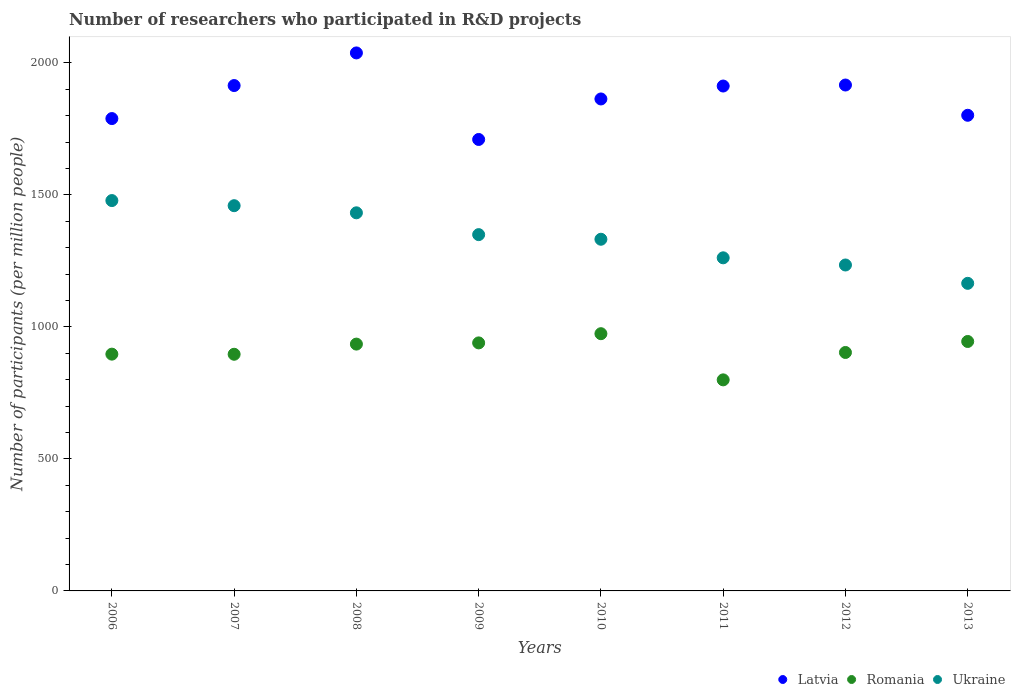Is the number of dotlines equal to the number of legend labels?
Your answer should be very brief. Yes. What is the number of researchers who participated in R&D projects in Ukraine in 2011?
Make the answer very short. 1261.86. Across all years, what is the maximum number of researchers who participated in R&D projects in Romania?
Offer a terse response. 974.44. Across all years, what is the minimum number of researchers who participated in R&D projects in Latvia?
Keep it short and to the point. 1710.19. In which year was the number of researchers who participated in R&D projects in Romania maximum?
Make the answer very short. 2010. What is the total number of researchers who participated in R&D projects in Ukraine in the graph?
Make the answer very short. 1.07e+04. What is the difference between the number of researchers who participated in R&D projects in Romania in 2006 and that in 2010?
Provide a short and direct response. -77.48. What is the difference between the number of researchers who participated in R&D projects in Latvia in 2006 and the number of researchers who participated in R&D projects in Ukraine in 2007?
Your response must be concise. 330.04. What is the average number of researchers who participated in R&D projects in Romania per year?
Keep it short and to the point. 911.28. In the year 2006, what is the difference between the number of researchers who participated in R&D projects in Latvia and number of researchers who participated in R&D projects in Ukraine?
Your response must be concise. 310.65. In how many years, is the number of researchers who participated in R&D projects in Latvia greater than 1100?
Offer a terse response. 8. What is the ratio of the number of researchers who participated in R&D projects in Ukraine in 2009 to that in 2011?
Keep it short and to the point. 1.07. What is the difference between the highest and the second highest number of researchers who participated in R&D projects in Latvia?
Offer a very short reply. 121.58. What is the difference between the highest and the lowest number of researchers who participated in R&D projects in Romania?
Ensure brevity in your answer.  174.9. In how many years, is the number of researchers who participated in R&D projects in Romania greater than the average number of researchers who participated in R&D projects in Romania taken over all years?
Keep it short and to the point. 4. Is it the case that in every year, the sum of the number of researchers who participated in R&D projects in Romania and number of researchers who participated in R&D projects in Ukraine  is greater than the number of researchers who participated in R&D projects in Latvia?
Provide a short and direct response. Yes. Is the number of researchers who participated in R&D projects in Latvia strictly greater than the number of researchers who participated in R&D projects in Romania over the years?
Your answer should be compact. Yes. How many years are there in the graph?
Offer a terse response. 8. Are the values on the major ticks of Y-axis written in scientific E-notation?
Offer a very short reply. No. Does the graph contain grids?
Your answer should be compact. No. How many legend labels are there?
Make the answer very short. 3. How are the legend labels stacked?
Give a very brief answer. Horizontal. What is the title of the graph?
Give a very brief answer. Number of researchers who participated in R&D projects. Does "Guinea" appear as one of the legend labels in the graph?
Your response must be concise. No. What is the label or title of the X-axis?
Provide a short and direct response. Years. What is the label or title of the Y-axis?
Provide a short and direct response. Number of participants (per million people). What is the Number of participants (per million people) in Latvia in 2006?
Make the answer very short. 1789.36. What is the Number of participants (per million people) in Romania in 2006?
Keep it short and to the point. 896.96. What is the Number of participants (per million people) of Ukraine in 2006?
Your response must be concise. 1478.72. What is the Number of participants (per million people) in Latvia in 2007?
Provide a short and direct response. 1914.45. What is the Number of participants (per million people) of Romania in 2007?
Offer a very short reply. 896.49. What is the Number of participants (per million people) of Ukraine in 2007?
Make the answer very short. 1459.32. What is the Number of participants (per million people) of Latvia in 2008?
Offer a terse response. 2038.04. What is the Number of participants (per million people) of Romania in 2008?
Your response must be concise. 935.03. What is the Number of participants (per million people) in Ukraine in 2008?
Your response must be concise. 1432.33. What is the Number of participants (per million people) in Latvia in 2009?
Keep it short and to the point. 1710.19. What is the Number of participants (per million people) in Romania in 2009?
Your answer should be compact. 939.58. What is the Number of participants (per million people) in Ukraine in 2009?
Your answer should be very brief. 1349.71. What is the Number of participants (per million people) of Latvia in 2010?
Ensure brevity in your answer.  1863.65. What is the Number of participants (per million people) in Romania in 2010?
Your answer should be very brief. 974.44. What is the Number of participants (per million people) in Ukraine in 2010?
Keep it short and to the point. 1332.2. What is the Number of participants (per million people) in Latvia in 2011?
Your answer should be compact. 1912.62. What is the Number of participants (per million people) of Romania in 2011?
Your answer should be very brief. 799.54. What is the Number of participants (per million people) in Ukraine in 2011?
Give a very brief answer. 1261.86. What is the Number of participants (per million people) in Latvia in 2012?
Offer a very short reply. 1916.46. What is the Number of participants (per million people) in Romania in 2012?
Your answer should be very brief. 903.29. What is the Number of participants (per million people) of Ukraine in 2012?
Your answer should be compact. 1234.66. What is the Number of participants (per million people) of Latvia in 2013?
Provide a succinct answer. 1801.82. What is the Number of participants (per million people) of Romania in 2013?
Make the answer very short. 944.93. What is the Number of participants (per million people) of Ukraine in 2013?
Your response must be concise. 1165.18. Across all years, what is the maximum Number of participants (per million people) of Latvia?
Keep it short and to the point. 2038.04. Across all years, what is the maximum Number of participants (per million people) in Romania?
Keep it short and to the point. 974.44. Across all years, what is the maximum Number of participants (per million people) in Ukraine?
Keep it short and to the point. 1478.72. Across all years, what is the minimum Number of participants (per million people) in Latvia?
Make the answer very short. 1710.19. Across all years, what is the minimum Number of participants (per million people) in Romania?
Keep it short and to the point. 799.54. Across all years, what is the minimum Number of participants (per million people) of Ukraine?
Offer a terse response. 1165.18. What is the total Number of participants (per million people) in Latvia in the graph?
Offer a terse response. 1.49e+04. What is the total Number of participants (per million people) in Romania in the graph?
Keep it short and to the point. 7290.24. What is the total Number of participants (per million people) of Ukraine in the graph?
Give a very brief answer. 1.07e+04. What is the difference between the Number of participants (per million people) in Latvia in 2006 and that in 2007?
Your answer should be very brief. -125.09. What is the difference between the Number of participants (per million people) in Romania in 2006 and that in 2007?
Your answer should be compact. 0.48. What is the difference between the Number of participants (per million people) of Ukraine in 2006 and that in 2007?
Provide a short and direct response. 19.39. What is the difference between the Number of participants (per million people) of Latvia in 2006 and that in 2008?
Give a very brief answer. -248.68. What is the difference between the Number of participants (per million people) in Romania in 2006 and that in 2008?
Ensure brevity in your answer.  -38.06. What is the difference between the Number of participants (per million people) of Ukraine in 2006 and that in 2008?
Your answer should be very brief. 46.39. What is the difference between the Number of participants (per million people) of Latvia in 2006 and that in 2009?
Your answer should be compact. 79.17. What is the difference between the Number of participants (per million people) of Romania in 2006 and that in 2009?
Give a very brief answer. -42.61. What is the difference between the Number of participants (per million people) of Ukraine in 2006 and that in 2009?
Offer a terse response. 129. What is the difference between the Number of participants (per million people) in Latvia in 2006 and that in 2010?
Your answer should be compact. -74.29. What is the difference between the Number of participants (per million people) of Romania in 2006 and that in 2010?
Your response must be concise. -77.48. What is the difference between the Number of participants (per million people) in Ukraine in 2006 and that in 2010?
Provide a succinct answer. 146.52. What is the difference between the Number of participants (per million people) of Latvia in 2006 and that in 2011?
Keep it short and to the point. -123.26. What is the difference between the Number of participants (per million people) in Romania in 2006 and that in 2011?
Provide a short and direct response. 97.43. What is the difference between the Number of participants (per million people) in Ukraine in 2006 and that in 2011?
Your answer should be compact. 216.86. What is the difference between the Number of participants (per million people) in Latvia in 2006 and that in 2012?
Ensure brevity in your answer.  -127.09. What is the difference between the Number of participants (per million people) of Romania in 2006 and that in 2012?
Ensure brevity in your answer.  -6.32. What is the difference between the Number of participants (per million people) in Ukraine in 2006 and that in 2012?
Provide a short and direct response. 244.05. What is the difference between the Number of participants (per million people) of Latvia in 2006 and that in 2013?
Provide a succinct answer. -12.45. What is the difference between the Number of participants (per million people) in Romania in 2006 and that in 2013?
Give a very brief answer. -47.96. What is the difference between the Number of participants (per million people) in Ukraine in 2006 and that in 2013?
Your answer should be compact. 313.53. What is the difference between the Number of participants (per million people) in Latvia in 2007 and that in 2008?
Offer a terse response. -123.59. What is the difference between the Number of participants (per million people) of Romania in 2007 and that in 2008?
Offer a very short reply. -38.54. What is the difference between the Number of participants (per million people) of Ukraine in 2007 and that in 2008?
Keep it short and to the point. 26.99. What is the difference between the Number of participants (per million people) in Latvia in 2007 and that in 2009?
Your response must be concise. 204.26. What is the difference between the Number of participants (per million people) in Romania in 2007 and that in 2009?
Give a very brief answer. -43.09. What is the difference between the Number of participants (per million people) of Ukraine in 2007 and that in 2009?
Provide a short and direct response. 109.61. What is the difference between the Number of participants (per million people) of Latvia in 2007 and that in 2010?
Provide a short and direct response. 50.8. What is the difference between the Number of participants (per million people) of Romania in 2007 and that in 2010?
Your response must be concise. -77.95. What is the difference between the Number of participants (per million people) in Ukraine in 2007 and that in 2010?
Your response must be concise. 127.12. What is the difference between the Number of participants (per million people) in Latvia in 2007 and that in 2011?
Provide a short and direct response. 1.83. What is the difference between the Number of participants (per million people) in Romania in 2007 and that in 2011?
Your answer should be compact. 96.95. What is the difference between the Number of participants (per million people) in Ukraine in 2007 and that in 2011?
Your response must be concise. 197.46. What is the difference between the Number of participants (per million people) in Latvia in 2007 and that in 2012?
Provide a short and direct response. -2.01. What is the difference between the Number of participants (per million people) in Romania in 2007 and that in 2012?
Give a very brief answer. -6.8. What is the difference between the Number of participants (per million people) in Ukraine in 2007 and that in 2012?
Provide a short and direct response. 224.66. What is the difference between the Number of participants (per million people) of Latvia in 2007 and that in 2013?
Keep it short and to the point. 112.63. What is the difference between the Number of participants (per million people) of Romania in 2007 and that in 2013?
Keep it short and to the point. -48.44. What is the difference between the Number of participants (per million people) of Ukraine in 2007 and that in 2013?
Your answer should be very brief. 294.14. What is the difference between the Number of participants (per million people) in Latvia in 2008 and that in 2009?
Make the answer very short. 327.85. What is the difference between the Number of participants (per million people) in Romania in 2008 and that in 2009?
Provide a short and direct response. -4.55. What is the difference between the Number of participants (per million people) in Ukraine in 2008 and that in 2009?
Offer a very short reply. 82.62. What is the difference between the Number of participants (per million people) in Latvia in 2008 and that in 2010?
Offer a terse response. 174.39. What is the difference between the Number of participants (per million people) in Romania in 2008 and that in 2010?
Your answer should be compact. -39.41. What is the difference between the Number of participants (per million people) of Ukraine in 2008 and that in 2010?
Keep it short and to the point. 100.13. What is the difference between the Number of participants (per million people) in Latvia in 2008 and that in 2011?
Offer a terse response. 125.42. What is the difference between the Number of participants (per million people) in Romania in 2008 and that in 2011?
Your answer should be compact. 135.49. What is the difference between the Number of participants (per million people) in Ukraine in 2008 and that in 2011?
Provide a succinct answer. 170.47. What is the difference between the Number of participants (per million people) of Latvia in 2008 and that in 2012?
Offer a very short reply. 121.58. What is the difference between the Number of participants (per million people) of Romania in 2008 and that in 2012?
Your response must be concise. 31.74. What is the difference between the Number of participants (per million people) of Ukraine in 2008 and that in 2012?
Make the answer very short. 197.67. What is the difference between the Number of participants (per million people) of Latvia in 2008 and that in 2013?
Your answer should be very brief. 236.22. What is the difference between the Number of participants (per million people) of Romania in 2008 and that in 2013?
Your answer should be very brief. -9.9. What is the difference between the Number of participants (per million people) in Ukraine in 2008 and that in 2013?
Give a very brief answer. 267.15. What is the difference between the Number of participants (per million people) of Latvia in 2009 and that in 2010?
Offer a terse response. -153.46. What is the difference between the Number of participants (per million people) of Romania in 2009 and that in 2010?
Your response must be concise. -34.86. What is the difference between the Number of participants (per million people) in Ukraine in 2009 and that in 2010?
Keep it short and to the point. 17.51. What is the difference between the Number of participants (per million people) of Latvia in 2009 and that in 2011?
Your answer should be very brief. -202.43. What is the difference between the Number of participants (per million people) of Romania in 2009 and that in 2011?
Your answer should be very brief. 140.04. What is the difference between the Number of participants (per million people) of Ukraine in 2009 and that in 2011?
Your response must be concise. 87.85. What is the difference between the Number of participants (per million people) in Latvia in 2009 and that in 2012?
Your answer should be very brief. -206.27. What is the difference between the Number of participants (per million people) in Romania in 2009 and that in 2012?
Offer a very short reply. 36.29. What is the difference between the Number of participants (per million people) of Ukraine in 2009 and that in 2012?
Give a very brief answer. 115.05. What is the difference between the Number of participants (per million people) of Latvia in 2009 and that in 2013?
Your answer should be compact. -91.63. What is the difference between the Number of participants (per million people) of Romania in 2009 and that in 2013?
Offer a very short reply. -5.35. What is the difference between the Number of participants (per million people) in Ukraine in 2009 and that in 2013?
Provide a short and direct response. 184.53. What is the difference between the Number of participants (per million people) in Latvia in 2010 and that in 2011?
Your answer should be compact. -48.97. What is the difference between the Number of participants (per million people) in Romania in 2010 and that in 2011?
Make the answer very short. 174.9. What is the difference between the Number of participants (per million people) of Ukraine in 2010 and that in 2011?
Offer a terse response. 70.34. What is the difference between the Number of participants (per million people) of Latvia in 2010 and that in 2012?
Give a very brief answer. -52.81. What is the difference between the Number of participants (per million people) of Romania in 2010 and that in 2012?
Provide a succinct answer. 71.15. What is the difference between the Number of participants (per million people) in Ukraine in 2010 and that in 2012?
Give a very brief answer. 97.54. What is the difference between the Number of participants (per million people) of Latvia in 2010 and that in 2013?
Your answer should be compact. 61.83. What is the difference between the Number of participants (per million people) of Romania in 2010 and that in 2013?
Your answer should be very brief. 29.52. What is the difference between the Number of participants (per million people) of Ukraine in 2010 and that in 2013?
Keep it short and to the point. 167.02. What is the difference between the Number of participants (per million people) of Latvia in 2011 and that in 2012?
Your response must be concise. -3.84. What is the difference between the Number of participants (per million people) in Romania in 2011 and that in 2012?
Keep it short and to the point. -103.75. What is the difference between the Number of participants (per million people) of Ukraine in 2011 and that in 2012?
Provide a succinct answer. 27.2. What is the difference between the Number of participants (per million people) of Latvia in 2011 and that in 2013?
Give a very brief answer. 110.8. What is the difference between the Number of participants (per million people) in Romania in 2011 and that in 2013?
Give a very brief answer. -145.39. What is the difference between the Number of participants (per million people) in Ukraine in 2011 and that in 2013?
Ensure brevity in your answer.  96.68. What is the difference between the Number of participants (per million people) of Latvia in 2012 and that in 2013?
Offer a terse response. 114.64. What is the difference between the Number of participants (per million people) in Romania in 2012 and that in 2013?
Provide a succinct answer. -41.64. What is the difference between the Number of participants (per million people) of Ukraine in 2012 and that in 2013?
Make the answer very short. 69.48. What is the difference between the Number of participants (per million people) of Latvia in 2006 and the Number of participants (per million people) of Romania in 2007?
Your answer should be compact. 892.88. What is the difference between the Number of participants (per million people) in Latvia in 2006 and the Number of participants (per million people) in Ukraine in 2007?
Offer a very short reply. 330.04. What is the difference between the Number of participants (per million people) in Romania in 2006 and the Number of participants (per million people) in Ukraine in 2007?
Give a very brief answer. -562.36. What is the difference between the Number of participants (per million people) in Latvia in 2006 and the Number of participants (per million people) in Romania in 2008?
Offer a terse response. 854.34. What is the difference between the Number of participants (per million people) of Latvia in 2006 and the Number of participants (per million people) of Ukraine in 2008?
Offer a terse response. 357.04. What is the difference between the Number of participants (per million people) in Romania in 2006 and the Number of participants (per million people) in Ukraine in 2008?
Your answer should be very brief. -535.36. What is the difference between the Number of participants (per million people) of Latvia in 2006 and the Number of participants (per million people) of Romania in 2009?
Provide a short and direct response. 849.79. What is the difference between the Number of participants (per million people) of Latvia in 2006 and the Number of participants (per million people) of Ukraine in 2009?
Give a very brief answer. 439.65. What is the difference between the Number of participants (per million people) in Romania in 2006 and the Number of participants (per million people) in Ukraine in 2009?
Make the answer very short. -452.75. What is the difference between the Number of participants (per million people) of Latvia in 2006 and the Number of participants (per million people) of Romania in 2010?
Your answer should be very brief. 814.92. What is the difference between the Number of participants (per million people) of Latvia in 2006 and the Number of participants (per million people) of Ukraine in 2010?
Offer a very short reply. 457.17. What is the difference between the Number of participants (per million people) in Romania in 2006 and the Number of participants (per million people) in Ukraine in 2010?
Give a very brief answer. -435.23. What is the difference between the Number of participants (per million people) in Latvia in 2006 and the Number of participants (per million people) in Romania in 2011?
Your answer should be compact. 989.83. What is the difference between the Number of participants (per million people) of Latvia in 2006 and the Number of participants (per million people) of Ukraine in 2011?
Your response must be concise. 527.5. What is the difference between the Number of participants (per million people) of Romania in 2006 and the Number of participants (per million people) of Ukraine in 2011?
Keep it short and to the point. -364.9. What is the difference between the Number of participants (per million people) in Latvia in 2006 and the Number of participants (per million people) in Romania in 2012?
Your response must be concise. 886.08. What is the difference between the Number of participants (per million people) in Latvia in 2006 and the Number of participants (per million people) in Ukraine in 2012?
Your answer should be very brief. 554.7. What is the difference between the Number of participants (per million people) of Romania in 2006 and the Number of participants (per million people) of Ukraine in 2012?
Make the answer very short. -337.7. What is the difference between the Number of participants (per million people) in Latvia in 2006 and the Number of participants (per million people) in Romania in 2013?
Your response must be concise. 844.44. What is the difference between the Number of participants (per million people) in Latvia in 2006 and the Number of participants (per million people) in Ukraine in 2013?
Give a very brief answer. 624.18. What is the difference between the Number of participants (per million people) of Romania in 2006 and the Number of participants (per million people) of Ukraine in 2013?
Your response must be concise. -268.22. What is the difference between the Number of participants (per million people) in Latvia in 2007 and the Number of participants (per million people) in Romania in 2008?
Make the answer very short. 979.43. What is the difference between the Number of participants (per million people) of Latvia in 2007 and the Number of participants (per million people) of Ukraine in 2008?
Ensure brevity in your answer.  482.12. What is the difference between the Number of participants (per million people) in Romania in 2007 and the Number of participants (per million people) in Ukraine in 2008?
Give a very brief answer. -535.84. What is the difference between the Number of participants (per million people) in Latvia in 2007 and the Number of participants (per million people) in Romania in 2009?
Give a very brief answer. 974.87. What is the difference between the Number of participants (per million people) of Latvia in 2007 and the Number of participants (per million people) of Ukraine in 2009?
Provide a succinct answer. 564.74. What is the difference between the Number of participants (per million people) of Romania in 2007 and the Number of participants (per million people) of Ukraine in 2009?
Your answer should be compact. -453.23. What is the difference between the Number of participants (per million people) in Latvia in 2007 and the Number of participants (per million people) in Romania in 2010?
Keep it short and to the point. 940.01. What is the difference between the Number of participants (per million people) of Latvia in 2007 and the Number of participants (per million people) of Ukraine in 2010?
Provide a succinct answer. 582.25. What is the difference between the Number of participants (per million people) in Romania in 2007 and the Number of participants (per million people) in Ukraine in 2010?
Make the answer very short. -435.71. What is the difference between the Number of participants (per million people) of Latvia in 2007 and the Number of participants (per million people) of Romania in 2011?
Ensure brevity in your answer.  1114.92. What is the difference between the Number of participants (per million people) of Latvia in 2007 and the Number of participants (per million people) of Ukraine in 2011?
Your answer should be compact. 652.59. What is the difference between the Number of participants (per million people) in Romania in 2007 and the Number of participants (per million people) in Ukraine in 2011?
Give a very brief answer. -365.38. What is the difference between the Number of participants (per million people) of Latvia in 2007 and the Number of participants (per million people) of Romania in 2012?
Offer a terse response. 1011.17. What is the difference between the Number of participants (per million people) of Latvia in 2007 and the Number of participants (per million people) of Ukraine in 2012?
Your answer should be very brief. 679.79. What is the difference between the Number of participants (per million people) in Romania in 2007 and the Number of participants (per million people) in Ukraine in 2012?
Offer a very short reply. -338.18. What is the difference between the Number of participants (per million people) in Latvia in 2007 and the Number of participants (per million people) in Romania in 2013?
Your response must be concise. 969.53. What is the difference between the Number of participants (per million people) of Latvia in 2007 and the Number of participants (per million people) of Ukraine in 2013?
Ensure brevity in your answer.  749.27. What is the difference between the Number of participants (per million people) in Romania in 2007 and the Number of participants (per million people) in Ukraine in 2013?
Your answer should be compact. -268.7. What is the difference between the Number of participants (per million people) of Latvia in 2008 and the Number of participants (per million people) of Romania in 2009?
Your response must be concise. 1098.46. What is the difference between the Number of participants (per million people) in Latvia in 2008 and the Number of participants (per million people) in Ukraine in 2009?
Your answer should be very brief. 688.33. What is the difference between the Number of participants (per million people) in Romania in 2008 and the Number of participants (per million people) in Ukraine in 2009?
Give a very brief answer. -414.68. What is the difference between the Number of participants (per million people) in Latvia in 2008 and the Number of participants (per million people) in Romania in 2010?
Your response must be concise. 1063.6. What is the difference between the Number of participants (per million people) of Latvia in 2008 and the Number of participants (per million people) of Ukraine in 2010?
Provide a short and direct response. 705.84. What is the difference between the Number of participants (per million people) in Romania in 2008 and the Number of participants (per million people) in Ukraine in 2010?
Your answer should be compact. -397.17. What is the difference between the Number of participants (per million people) of Latvia in 2008 and the Number of participants (per million people) of Romania in 2011?
Ensure brevity in your answer.  1238.51. What is the difference between the Number of participants (per million people) of Latvia in 2008 and the Number of participants (per million people) of Ukraine in 2011?
Offer a terse response. 776.18. What is the difference between the Number of participants (per million people) in Romania in 2008 and the Number of participants (per million people) in Ukraine in 2011?
Your answer should be very brief. -326.83. What is the difference between the Number of participants (per million people) of Latvia in 2008 and the Number of participants (per million people) of Romania in 2012?
Your answer should be compact. 1134.76. What is the difference between the Number of participants (per million people) of Latvia in 2008 and the Number of participants (per million people) of Ukraine in 2012?
Your answer should be very brief. 803.38. What is the difference between the Number of participants (per million people) in Romania in 2008 and the Number of participants (per million people) in Ukraine in 2012?
Ensure brevity in your answer.  -299.64. What is the difference between the Number of participants (per million people) in Latvia in 2008 and the Number of participants (per million people) in Romania in 2013?
Provide a succinct answer. 1093.12. What is the difference between the Number of participants (per million people) of Latvia in 2008 and the Number of participants (per million people) of Ukraine in 2013?
Your answer should be very brief. 872.86. What is the difference between the Number of participants (per million people) in Romania in 2008 and the Number of participants (per million people) in Ukraine in 2013?
Provide a short and direct response. -230.16. What is the difference between the Number of participants (per million people) of Latvia in 2009 and the Number of participants (per million people) of Romania in 2010?
Keep it short and to the point. 735.75. What is the difference between the Number of participants (per million people) in Latvia in 2009 and the Number of participants (per million people) in Ukraine in 2010?
Keep it short and to the point. 377.99. What is the difference between the Number of participants (per million people) of Romania in 2009 and the Number of participants (per million people) of Ukraine in 2010?
Your answer should be compact. -392.62. What is the difference between the Number of participants (per million people) in Latvia in 2009 and the Number of participants (per million people) in Romania in 2011?
Keep it short and to the point. 910.66. What is the difference between the Number of participants (per million people) in Latvia in 2009 and the Number of participants (per million people) in Ukraine in 2011?
Your answer should be very brief. 448.33. What is the difference between the Number of participants (per million people) in Romania in 2009 and the Number of participants (per million people) in Ukraine in 2011?
Provide a succinct answer. -322.28. What is the difference between the Number of participants (per million people) in Latvia in 2009 and the Number of participants (per million people) in Romania in 2012?
Ensure brevity in your answer.  806.91. What is the difference between the Number of participants (per million people) in Latvia in 2009 and the Number of participants (per million people) in Ukraine in 2012?
Provide a short and direct response. 475.53. What is the difference between the Number of participants (per million people) in Romania in 2009 and the Number of participants (per million people) in Ukraine in 2012?
Provide a succinct answer. -295.08. What is the difference between the Number of participants (per million people) in Latvia in 2009 and the Number of participants (per million people) in Romania in 2013?
Your response must be concise. 765.27. What is the difference between the Number of participants (per million people) in Latvia in 2009 and the Number of participants (per million people) in Ukraine in 2013?
Your answer should be compact. 545.01. What is the difference between the Number of participants (per million people) in Romania in 2009 and the Number of participants (per million people) in Ukraine in 2013?
Offer a very short reply. -225.6. What is the difference between the Number of participants (per million people) in Latvia in 2010 and the Number of participants (per million people) in Romania in 2011?
Provide a succinct answer. 1064.12. What is the difference between the Number of participants (per million people) of Latvia in 2010 and the Number of participants (per million people) of Ukraine in 2011?
Offer a very short reply. 601.79. What is the difference between the Number of participants (per million people) of Romania in 2010 and the Number of participants (per million people) of Ukraine in 2011?
Your answer should be very brief. -287.42. What is the difference between the Number of participants (per million people) in Latvia in 2010 and the Number of participants (per million people) in Romania in 2012?
Your response must be concise. 960.37. What is the difference between the Number of participants (per million people) in Latvia in 2010 and the Number of participants (per million people) in Ukraine in 2012?
Your answer should be very brief. 628.99. What is the difference between the Number of participants (per million people) in Romania in 2010 and the Number of participants (per million people) in Ukraine in 2012?
Make the answer very short. -260.22. What is the difference between the Number of participants (per million people) of Latvia in 2010 and the Number of participants (per million people) of Romania in 2013?
Your answer should be very brief. 918.73. What is the difference between the Number of participants (per million people) in Latvia in 2010 and the Number of participants (per million people) in Ukraine in 2013?
Offer a terse response. 698.47. What is the difference between the Number of participants (per million people) in Romania in 2010 and the Number of participants (per million people) in Ukraine in 2013?
Your response must be concise. -190.74. What is the difference between the Number of participants (per million people) in Latvia in 2011 and the Number of participants (per million people) in Romania in 2012?
Provide a succinct answer. 1009.33. What is the difference between the Number of participants (per million people) in Latvia in 2011 and the Number of participants (per million people) in Ukraine in 2012?
Keep it short and to the point. 677.96. What is the difference between the Number of participants (per million people) of Romania in 2011 and the Number of participants (per million people) of Ukraine in 2012?
Give a very brief answer. -435.13. What is the difference between the Number of participants (per million people) of Latvia in 2011 and the Number of participants (per million people) of Romania in 2013?
Keep it short and to the point. 967.7. What is the difference between the Number of participants (per million people) in Latvia in 2011 and the Number of participants (per million people) in Ukraine in 2013?
Offer a very short reply. 747.44. What is the difference between the Number of participants (per million people) of Romania in 2011 and the Number of participants (per million people) of Ukraine in 2013?
Provide a succinct answer. -365.65. What is the difference between the Number of participants (per million people) of Latvia in 2012 and the Number of participants (per million people) of Romania in 2013?
Keep it short and to the point. 971.53. What is the difference between the Number of participants (per million people) in Latvia in 2012 and the Number of participants (per million people) in Ukraine in 2013?
Offer a very short reply. 751.28. What is the difference between the Number of participants (per million people) of Romania in 2012 and the Number of participants (per million people) of Ukraine in 2013?
Ensure brevity in your answer.  -261.9. What is the average Number of participants (per million people) of Latvia per year?
Ensure brevity in your answer.  1868.32. What is the average Number of participants (per million people) of Romania per year?
Provide a succinct answer. 911.28. What is the average Number of participants (per million people) of Ukraine per year?
Keep it short and to the point. 1339.25. In the year 2006, what is the difference between the Number of participants (per million people) of Latvia and Number of participants (per million people) of Romania?
Give a very brief answer. 892.4. In the year 2006, what is the difference between the Number of participants (per million people) in Latvia and Number of participants (per million people) in Ukraine?
Your answer should be compact. 310.65. In the year 2006, what is the difference between the Number of participants (per million people) of Romania and Number of participants (per million people) of Ukraine?
Offer a very short reply. -581.75. In the year 2007, what is the difference between the Number of participants (per million people) in Latvia and Number of participants (per million people) in Romania?
Give a very brief answer. 1017.97. In the year 2007, what is the difference between the Number of participants (per million people) of Latvia and Number of participants (per million people) of Ukraine?
Offer a very short reply. 455.13. In the year 2007, what is the difference between the Number of participants (per million people) of Romania and Number of participants (per million people) of Ukraine?
Make the answer very short. -562.84. In the year 2008, what is the difference between the Number of participants (per million people) of Latvia and Number of participants (per million people) of Romania?
Provide a succinct answer. 1103.02. In the year 2008, what is the difference between the Number of participants (per million people) of Latvia and Number of participants (per million people) of Ukraine?
Your response must be concise. 605.71. In the year 2008, what is the difference between the Number of participants (per million people) in Romania and Number of participants (per million people) in Ukraine?
Offer a terse response. -497.3. In the year 2009, what is the difference between the Number of participants (per million people) of Latvia and Number of participants (per million people) of Romania?
Ensure brevity in your answer.  770.61. In the year 2009, what is the difference between the Number of participants (per million people) in Latvia and Number of participants (per million people) in Ukraine?
Make the answer very short. 360.48. In the year 2009, what is the difference between the Number of participants (per million people) of Romania and Number of participants (per million people) of Ukraine?
Offer a terse response. -410.13. In the year 2010, what is the difference between the Number of participants (per million people) in Latvia and Number of participants (per million people) in Romania?
Keep it short and to the point. 889.21. In the year 2010, what is the difference between the Number of participants (per million people) of Latvia and Number of participants (per million people) of Ukraine?
Provide a succinct answer. 531.45. In the year 2010, what is the difference between the Number of participants (per million people) of Romania and Number of participants (per million people) of Ukraine?
Make the answer very short. -357.76. In the year 2011, what is the difference between the Number of participants (per million people) in Latvia and Number of participants (per million people) in Romania?
Keep it short and to the point. 1113.08. In the year 2011, what is the difference between the Number of participants (per million people) of Latvia and Number of participants (per million people) of Ukraine?
Offer a very short reply. 650.76. In the year 2011, what is the difference between the Number of participants (per million people) of Romania and Number of participants (per million people) of Ukraine?
Provide a succinct answer. -462.32. In the year 2012, what is the difference between the Number of participants (per million people) in Latvia and Number of participants (per million people) in Romania?
Offer a very short reply. 1013.17. In the year 2012, what is the difference between the Number of participants (per million people) in Latvia and Number of participants (per million people) in Ukraine?
Make the answer very short. 681.8. In the year 2012, what is the difference between the Number of participants (per million people) in Romania and Number of participants (per million people) in Ukraine?
Give a very brief answer. -331.38. In the year 2013, what is the difference between the Number of participants (per million people) of Latvia and Number of participants (per million people) of Romania?
Your answer should be compact. 856.89. In the year 2013, what is the difference between the Number of participants (per million people) in Latvia and Number of participants (per million people) in Ukraine?
Give a very brief answer. 636.64. In the year 2013, what is the difference between the Number of participants (per million people) of Romania and Number of participants (per million people) of Ukraine?
Keep it short and to the point. -220.26. What is the ratio of the Number of participants (per million people) of Latvia in 2006 to that in 2007?
Give a very brief answer. 0.93. What is the ratio of the Number of participants (per million people) of Ukraine in 2006 to that in 2007?
Offer a terse response. 1.01. What is the ratio of the Number of participants (per million people) of Latvia in 2006 to that in 2008?
Your answer should be compact. 0.88. What is the ratio of the Number of participants (per million people) in Romania in 2006 to that in 2008?
Your response must be concise. 0.96. What is the ratio of the Number of participants (per million people) in Ukraine in 2006 to that in 2008?
Make the answer very short. 1.03. What is the ratio of the Number of participants (per million people) in Latvia in 2006 to that in 2009?
Make the answer very short. 1.05. What is the ratio of the Number of participants (per million people) in Romania in 2006 to that in 2009?
Provide a succinct answer. 0.95. What is the ratio of the Number of participants (per million people) of Ukraine in 2006 to that in 2009?
Offer a very short reply. 1.1. What is the ratio of the Number of participants (per million people) in Latvia in 2006 to that in 2010?
Your answer should be very brief. 0.96. What is the ratio of the Number of participants (per million people) of Romania in 2006 to that in 2010?
Make the answer very short. 0.92. What is the ratio of the Number of participants (per million people) of Ukraine in 2006 to that in 2010?
Make the answer very short. 1.11. What is the ratio of the Number of participants (per million people) of Latvia in 2006 to that in 2011?
Ensure brevity in your answer.  0.94. What is the ratio of the Number of participants (per million people) of Romania in 2006 to that in 2011?
Ensure brevity in your answer.  1.12. What is the ratio of the Number of participants (per million people) in Ukraine in 2006 to that in 2011?
Offer a terse response. 1.17. What is the ratio of the Number of participants (per million people) in Latvia in 2006 to that in 2012?
Ensure brevity in your answer.  0.93. What is the ratio of the Number of participants (per million people) of Romania in 2006 to that in 2012?
Ensure brevity in your answer.  0.99. What is the ratio of the Number of participants (per million people) in Ukraine in 2006 to that in 2012?
Offer a very short reply. 1.2. What is the ratio of the Number of participants (per million people) in Romania in 2006 to that in 2013?
Your response must be concise. 0.95. What is the ratio of the Number of participants (per million people) of Ukraine in 2006 to that in 2013?
Make the answer very short. 1.27. What is the ratio of the Number of participants (per million people) of Latvia in 2007 to that in 2008?
Make the answer very short. 0.94. What is the ratio of the Number of participants (per million people) in Romania in 2007 to that in 2008?
Keep it short and to the point. 0.96. What is the ratio of the Number of participants (per million people) of Ukraine in 2007 to that in 2008?
Offer a very short reply. 1.02. What is the ratio of the Number of participants (per million people) of Latvia in 2007 to that in 2009?
Provide a short and direct response. 1.12. What is the ratio of the Number of participants (per million people) in Romania in 2007 to that in 2009?
Provide a short and direct response. 0.95. What is the ratio of the Number of participants (per million people) in Ukraine in 2007 to that in 2009?
Your answer should be very brief. 1.08. What is the ratio of the Number of participants (per million people) of Latvia in 2007 to that in 2010?
Give a very brief answer. 1.03. What is the ratio of the Number of participants (per million people) in Ukraine in 2007 to that in 2010?
Offer a terse response. 1.1. What is the ratio of the Number of participants (per million people) of Latvia in 2007 to that in 2011?
Provide a short and direct response. 1. What is the ratio of the Number of participants (per million people) of Romania in 2007 to that in 2011?
Your answer should be very brief. 1.12. What is the ratio of the Number of participants (per million people) of Ukraine in 2007 to that in 2011?
Ensure brevity in your answer.  1.16. What is the ratio of the Number of participants (per million people) of Romania in 2007 to that in 2012?
Your answer should be very brief. 0.99. What is the ratio of the Number of participants (per million people) in Ukraine in 2007 to that in 2012?
Provide a succinct answer. 1.18. What is the ratio of the Number of participants (per million people) in Romania in 2007 to that in 2013?
Offer a very short reply. 0.95. What is the ratio of the Number of participants (per million people) of Ukraine in 2007 to that in 2013?
Give a very brief answer. 1.25. What is the ratio of the Number of participants (per million people) of Latvia in 2008 to that in 2009?
Keep it short and to the point. 1.19. What is the ratio of the Number of participants (per million people) of Romania in 2008 to that in 2009?
Offer a terse response. 1. What is the ratio of the Number of participants (per million people) of Ukraine in 2008 to that in 2009?
Your answer should be compact. 1.06. What is the ratio of the Number of participants (per million people) in Latvia in 2008 to that in 2010?
Offer a terse response. 1.09. What is the ratio of the Number of participants (per million people) in Romania in 2008 to that in 2010?
Your answer should be compact. 0.96. What is the ratio of the Number of participants (per million people) of Ukraine in 2008 to that in 2010?
Make the answer very short. 1.08. What is the ratio of the Number of participants (per million people) in Latvia in 2008 to that in 2011?
Give a very brief answer. 1.07. What is the ratio of the Number of participants (per million people) in Romania in 2008 to that in 2011?
Provide a succinct answer. 1.17. What is the ratio of the Number of participants (per million people) of Ukraine in 2008 to that in 2011?
Offer a very short reply. 1.14. What is the ratio of the Number of participants (per million people) of Latvia in 2008 to that in 2012?
Offer a terse response. 1.06. What is the ratio of the Number of participants (per million people) in Romania in 2008 to that in 2012?
Offer a terse response. 1.04. What is the ratio of the Number of participants (per million people) in Ukraine in 2008 to that in 2012?
Offer a terse response. 1.16. What is the ratio of the Number of participants (per million people) in Latvia in 2008 to that in 2013?
Ensure brevity in your answer.  1.13. What is the ratio of the Number of participants (per million people) of Romania in 2008 to that in 2013?
Offer a very short reply. 0.99. What is the ratio of the Number of participants (per million people) in Ukraine in 2008 to that in 2013?
Ensure brevity in your answer.  1.23. What is the ratio of the Number of participants (per million people) in Latvia in 2009 to that in 2010?
Provide a short and direct response. 0.92. What is the ratio of the Number of participants (per million people) in Romania in 2009 to that in 2010?
Your answer should be very brief. 0.96. What is the ratio of the Number of participants (per million people) in Ukraine in 2009 to that in 2010?
Provide a short and direct response. 1.01. What is the ratio of the Number of participants (per million people) in Latvia in 2009 to that in 2011?
Provide a short and direct response. 0.89. What is the ratio of the Number of participants (per million people) of Romania in 2009 to that in 2011?
Your answer should be compact. 1.18. What is the ratio of the Number of participants (per million people) in Ukraine in 2009 to that in 2011?
Your response must be concise. 1.07. What is the ratio of the Number of participants (per million people) in Latvia in 2009 to that in 2012?
Provide a short and direct response. 0.89. What is the ratio of the Number of participants (per million people) in Romania in 2009 to that in 2012?
Provide a succinct answer. 1.04. What is the ratio of the Number of participants (per million people) in Ukraine in 2009 to that in 2012?
Make the answer very short. 1.09. What is the ratio of the Number of participants (per million people) in Latvia in 2009 to that in 2013?
Your answer should be compact. 0.95. What is the ratio of the Number of participants (per million people) in Romania in 2009 to that in 2013?
Ensure brevity in your answer.  0.99. What is the ratio of the Number of participants (per million people) in Ukraine in 2009 to that in 2013?
Provide a succinct answer. 1.16. What is the ratio of the Number of participants (per million people) in Latvia in 2010 to that in 2011?
Provide a succinct answer. 0.97. What is the ratio of the Number of participants (per million people) in Romania in 2010 to that in 2011?
Make the answer very short. 1.22. What is the ratio of the Number of participants (per million people) of Ukraine in 2010 to that in 2011?
Provide a succinct answer. 1.06. What is the ratio of the Number of participants (per million people) of Latvia in 2010 to that in 2012?
Offer a very short reply. 0.97. What is the ratio of the Number of participants (per million people) in Romania in 2010 to that in 2012?
Provide a succinct answer. 1.08. What is the ratio of the Number of participants (per million people) in Ukraine in 2010 to that in 2012?
Your answer should be compact. 1.08. What is the ratio of the Number of participants (per million people) of Latvia in 2010 to that in 2013?
Provide a short and direct response. 1.03. What is the ratio of the Number of participants (per million people) in Romania in 2010 to that in 2013?
Give a very brief answer. 1.03. What is the ratio of the Number of participants (per million people) of Ukraine in 2010 to that in 2013?
Keep it short and to the point. 1.14. What is the ratio of the Number of participants (per million people) of Romania in 2011 to that in 2012?
Ensure brevity in your answer.  0.89. What is the ratio of the Number of participants (per million people) in Latvia in 2011 to that in 2013?
Provide a short and direct response. 1.06. What is the ratio of the Number of participants (per million people) in Romania in 2011 to that in 2013?
Ensure brevity in your answer.  0.85. What is the ratio of the Number of participants (per million people) of Ukraine in 2011 to that in 2013?
Offer a very short reply. 1.08. What is the ratio of the Number of participants (per million people) of Latvia in 2012 to that in 2013?
Make the answer very short. 1.06. What is the ratio of the Number of participants (per million people) in Romania in 2012 to that in 2013?
Provide a short and direct response. 0.96. What is the ratio of the Number of participants (per million people) of Ukraine in 2012 to that in 2013?
Your answer should be compact. 1.06. What is the difference between the highest and the second highest Number of participants (per million people) of Latvia?
Offer a very short reply. 121.58. What is the difference between the highest and the second highest Number of participants (per million people) in Romania?
Ensure brevity in your answer.  29.52. What is the difference between the highest and the second highest Number of participants (per million people) of Ukraine?
Make the answer very short. 19.39. What is the difference between the highest and the lowest Number of participants (per million people) in Latvia?
Your answer should be compact. 327.85. What is the difference between the highest and the lowest Number of participants (per million people) in Romania?
Offer a very short reply. 174.9. What is the difference between the highest and the lowest Number of participants (per million people) of Ukraine?
Give a very brief answer. 313.53. 